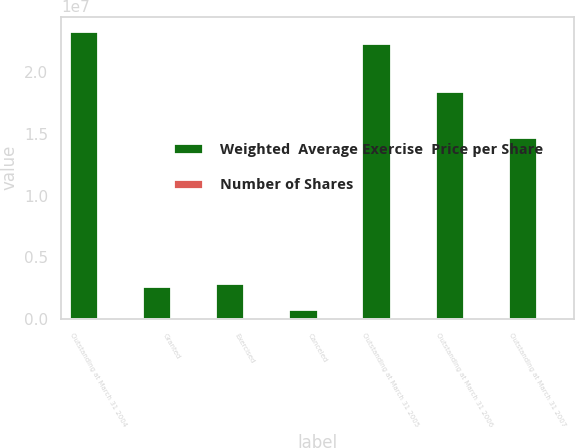Convert chart to OTSL. <chart><loc_0><loc_0><loc_500><loc_500><stacked_bar_chart><ecel><fcel>Outstanding at March 31 2004<fcel>Granted<fcel>Exercised<fcel>Canceled<fcel>Outstanding at March 31 2005<fcel>Outstanding at March 31 2006<fcel>Outstanding at March 31 2007<nl><fcel>Weighted  Average Exercise  Price per Share<fcel>2.33599e+07<fcel>2.69382e+06<fcel>2.88183e+06<fcel>801236<fcel>2.23707e+07<fcel>1.84504e+07<fcel>1.47405e+07<nl><fcel>Number of Shares<fcel>17.6<fcel>27.35<fcel>12.78<fcel>23.34<fcel>19.19<fcel>20.97<fcel>21.88<nl></chart> 